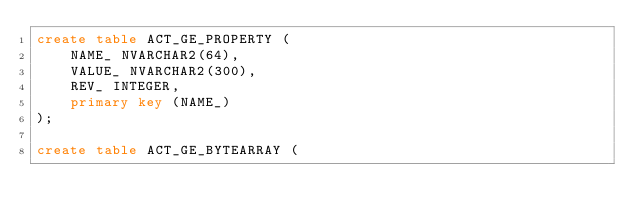<code> <loc_0><loc_0><loc_500><loc_500><_SQL_>create table ACT_GE_PROPERTY (
    NAME_ NVARCHAR2(64),
    VALUE_ NVARCHAR2(300),
    REV_ INTEGER,
    primary key (NAME_)
);

create table ACT_GE_BYTEARRAY (</code> 